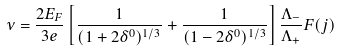Convert formula to latex. <formula><loc_0><loc_0><loc_500><loc_500>\nu = \frac { 2 E _ { F } } { 3 e } \left [ \frac { 1 } { ( 1 + 2 \delta ^ { 0 } ) ^ { 1 / 3 } } + \frac { 1 } { ( 1 - 2 \delta ^ { 0 } ) ^ { 1 / 3 } } \right ] \frac { \Lambda _ { - } } { \Lambda _ { + } } F ( j )</formula> 